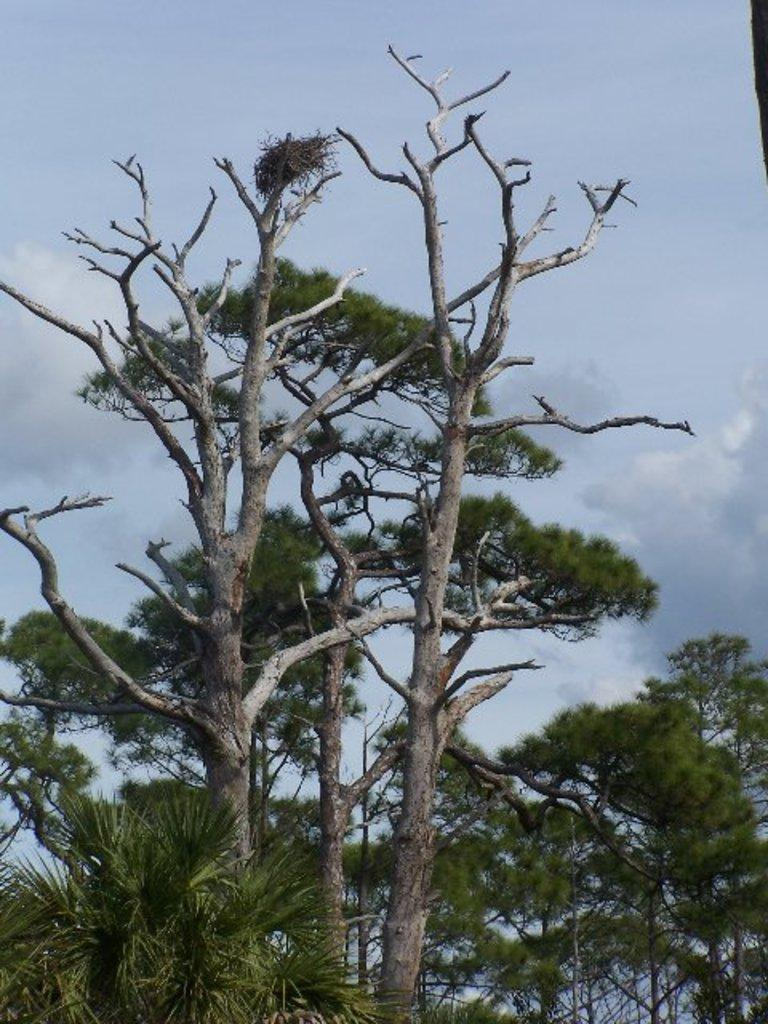What type of vegetation can be seen in the image? There are trees in the image. What is visible in the background of the image? The sky is visible in the background of the image. Can you describe the sky in the image? The sky appears to be cloudy in the image. What type of pin can be seen holding a shirt in the image? There is no pin or shirt present in the image; it only features trees and a cloudy sky. 